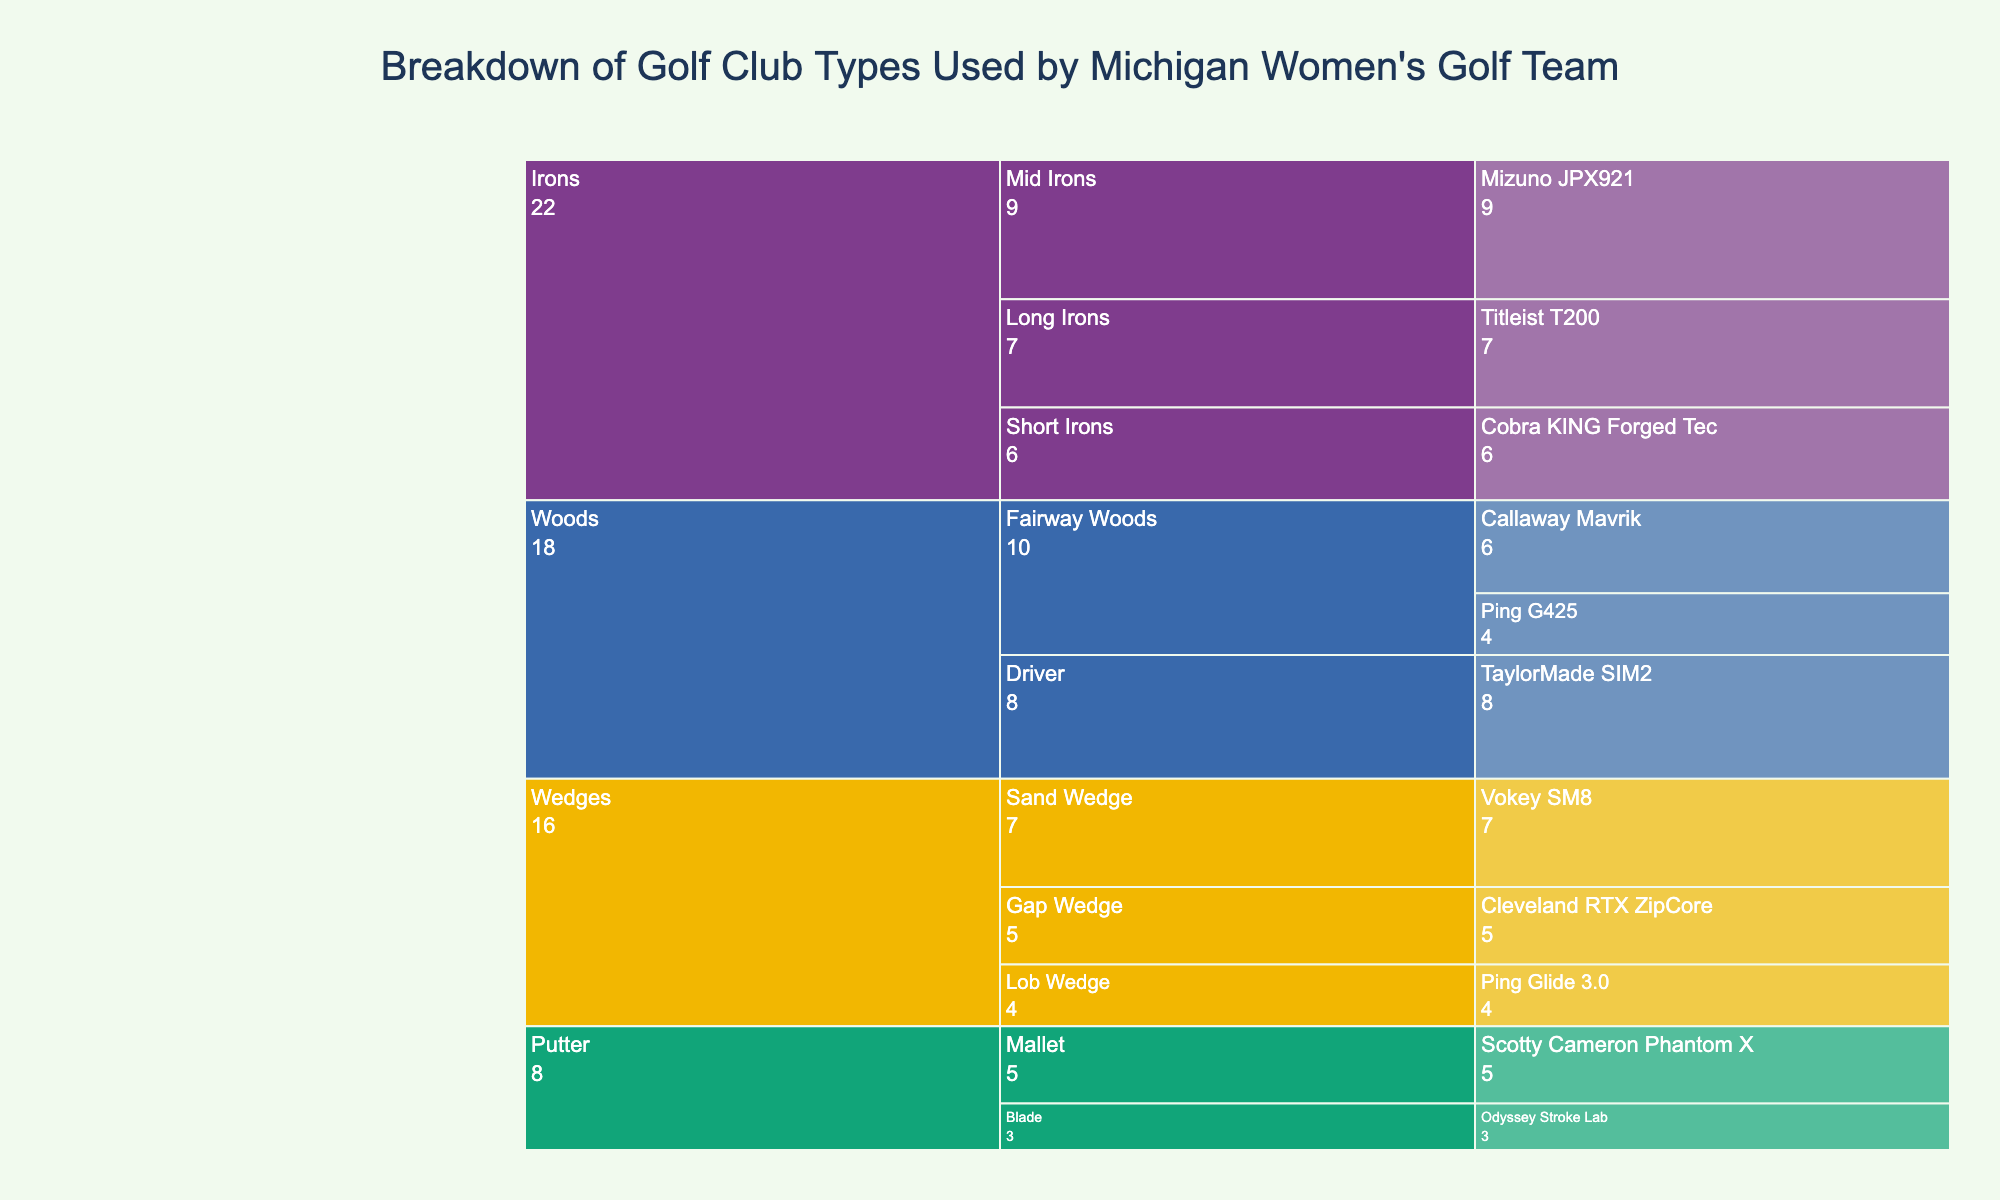What is the title of the icicle chart? The title of the chart is usually displayed prominently at the top. It describes the main subject or purpose of the visualization.
Answer: Breakdown of Golf Club Types Used by Michigan Women's Golf Team Which category has the most subcategories? The icicle chart shows the hierarchical arrangement of categories and subcategories. By examining the branches under each main category, we can determine which one has the most subcategories.
Answer: Wedges How many total clubs are in the Woods category? Look at each club count under the Woods category and sum them up. The Woods category includes Driver and Fairway Woods with respective counts.
Answer: 8 + 6 + 4 = 18 Which club has the highest count overall? Identify the club with the largest numerical value assigned to it, indicated in the chart. This club is the most frequently used.
Answer: Mizuno JPX921 (9) How many more Mid Irons are there compared to Long Irons? First, find the counts of both Mid Irons and Long Irons. Then, subtract the count of Long Irons from the count of Mid Irons.
Answer: 9 - 7 = 2 Which subcategory under Wedges has the fewest clubs? To find this, look at the counts of each subcategory under Wedges and identify the one with the smallest number.
Answer: Lob Wedge (4) Is there an equal number of clubs in any subcategories within the Irons category? Compare the counts of the subcategories within the Irons category to see if any two have the same number of clubs.
Answer: No How does the number of clubs in the Mallet subcategory compare to the Blade subcategory? Look at the counts for Mallet and Blade putters and determine which is greater, and by how much.
Answer: Mallet (5) is greater than Blade (3) by 2 clubs What is the total number of clubs used by the Michigan women's golf team? Add up the counts of all the clubs in the dataset to find the total number.
Answer: 8 + 6 + 4 + 7 + 9 + 6 + 5 + 7 + 4 + 3 + 5 = 64 What are the three most common clubs used by the team? Identify the three clubs with the highest counts from the icicle chart. These are the most frequently used clubs by the team.
Answer: Mizuno JPX921 (9), TaylorMade SIM2 (8), and Titleist T200 (7) 